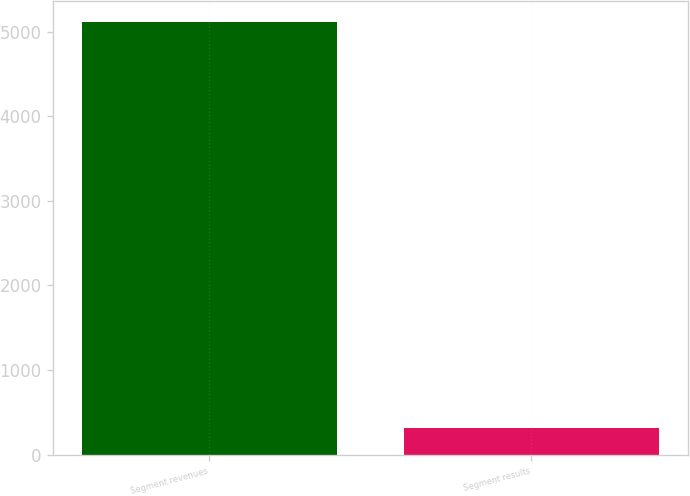<chart> <loc_0><loc_0><loc_500><loc_500><bar_chart><fcel>Segment revenues<fcel>Segment results<nl><fcel>5108<fcel>318<nl></chart> 